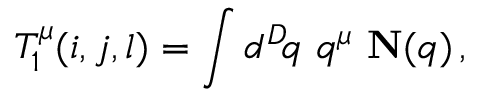Convert formula to latex. <formula><loc_0><loc_0><loc_500><loc_500>T _ { 1 } ^ { \mu } ( i , j , l ) = \int d ^ { D } \, q \, q ^ { \mu } \, { N } ( q ) \, ,</formula> 